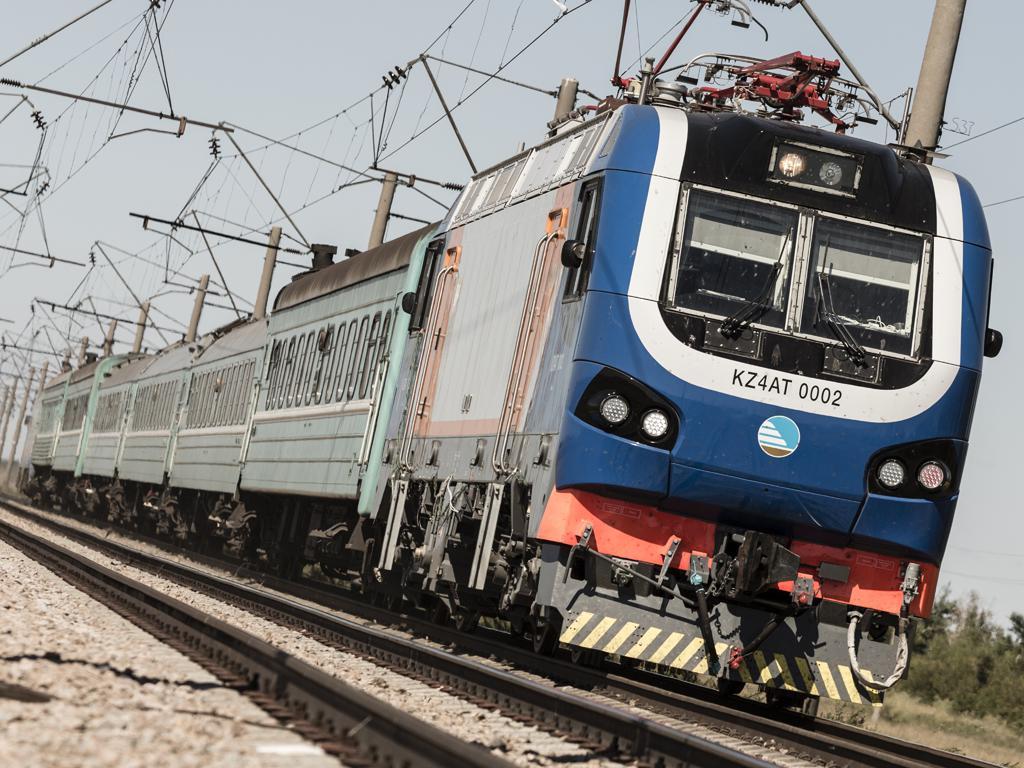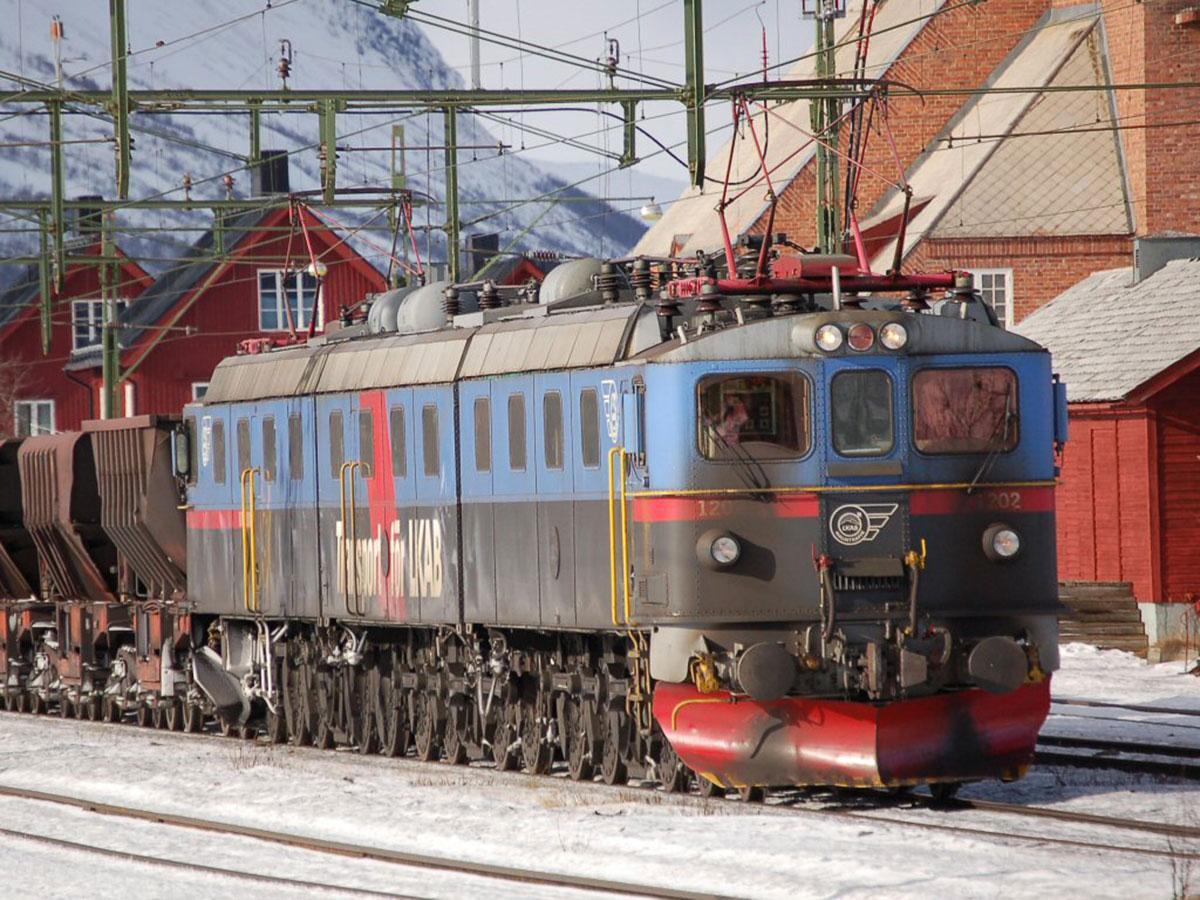The first image is the image on the left, the second image is the image on the right. For the images shown, is this caption "There is a white stripe all the way around the bottom of the train in the image on the right." true? Answer yes or no. No. 